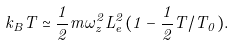Convert formula to latex. <formula><loc_0><loc_0><loc_500><loc_500>k _ { B } T \simeq \frac { 1 } { 2 } m \omega _ { z } ^ { 2 } L _ { e } ^ { 2 } ( 1 - \frac { 1 } { 2 } T / T _ { 0 } ) .</formula> 